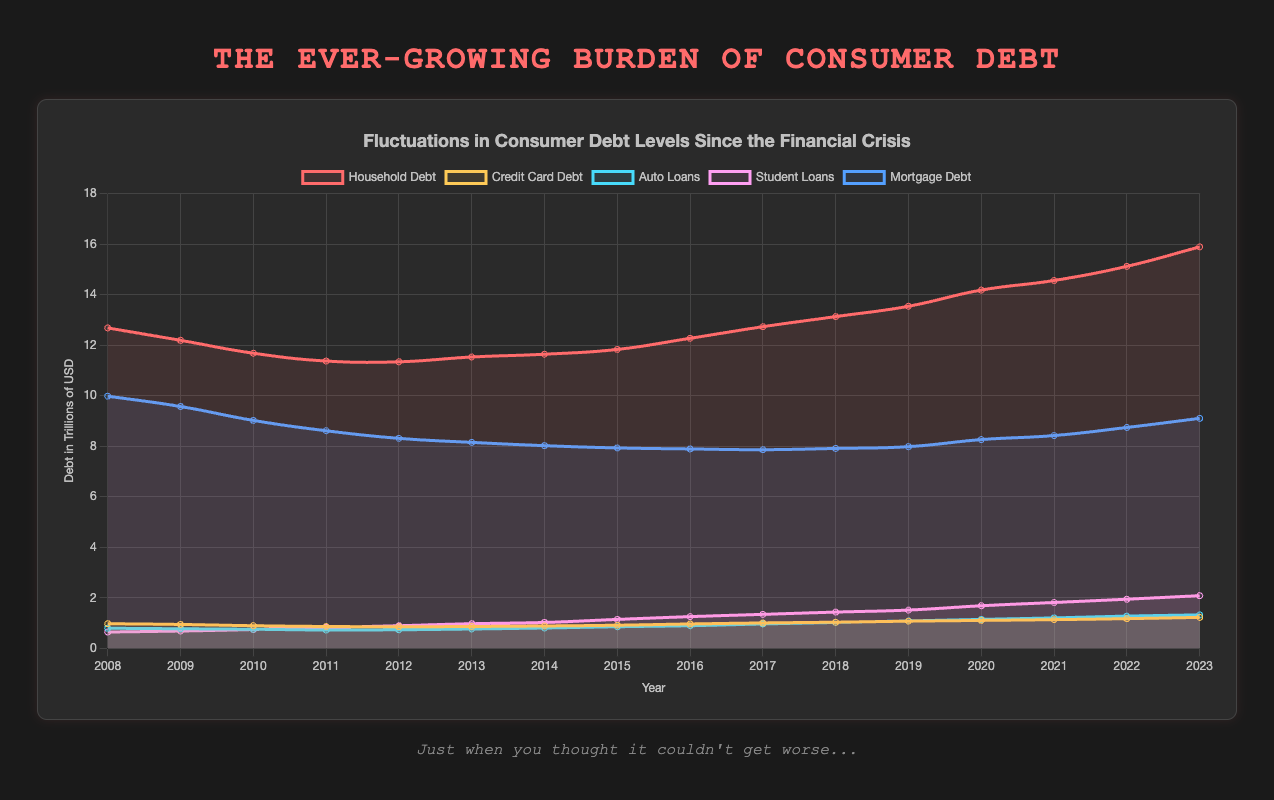Which type of debt has seen the highest increase from 2008 to 2023? To determine the highest increase, subtract the 2008 debt values from the 2023 values for each debt type. Household Debt: 15.89 - 12.68 = 3.21, Credit Card Debt: 1.22 - 0.97 = 0.25, Auto Loans: 1.32 - 0.79 = 0.53, Student Loans: 2.08 - 0.64 = 1.44, Mortgage Debt: 9.1 - 9.98 = -0.88. Student Loans have the highest increase of 1.44 trillion USD.
Answer: Student Loans Which debt category shows the most consistent upward trend across the years? To answer, observe the slopes of the lines representing each debt category. Student Loans demonstrate the most consistent upward trend as it continuously increases from 2008 to 2023 without any decline.
Answer: Student Loans In which year did Household Debt surpass the 13 trillion USD mark? Check the Household Debt line for the year where the value exceeds 13 trillion USD. The chart shows that in 2018, Household Debt is at 13.13 trillion USD, marking the first year it surpasses 13 trillion.
Answer: 2018 By how much did mortgage debt decrease from 2008 to its lowest point? Identify the highest point (2008, 9.98 trillion USD) and the lowest point (2014, 8.02 trillion USD). Calculate the decrease as 9.98 - 8.02 = 1.96 trillion USD.
Answer: 1.96 trillion USD Which debt type had the smallest average annual increase? Calculate the total increase for each debt type from 2008 to 2023 and divide by 15 years to find the average annual increase. Mortgage Debt: (-0.88)/15 ≈ -0.059, Household Debt: 3.21/15 ≈ 0.214, Credit Card Debt: 0.25/15 ≈ 0.017, Auto Loans: 0.53/15 ≈ 0.035, Student Loans: 1.44/15 ≈ 0.096. Credit Card Debt has the smallest average annual increase.
Answer: Credit Card Debt What is the total debt for all categories in 2023? Sum the 2023 debt values for each category: 15.89 (Household) + 1.22 (Credit Card) + 1.32 (Auto Loans) + 2.08 (Student Loans) + 9.1 (Mortgage) = 29.61 trillion USD.
Answer: 29.61 trillion USD Compare the mortgage debt in 2008 and in 2023. Which year had higher mortgage debt and by how much? Compare values from 2008 (9.98 trillion USD) and 2023 (9.1 trillion USD). 2008 had higher mortgage debt. The difference is 9.98 - 9.1 = 0.88 trillion USD.
Answer: 2008 by 0.88 trillion USD Which year had the lowest credit card debt and what was its value? Examine the Credit Card Debt line for the lowest point. In 2012, Credit Card Debt is at its lowest with 0.85 trillion USD.
Answer: 2012, 0.85 trillion USD What is the rate of increase in student loans from 2018 to 2023? Calculate the difference in student loans from 2018 (1.43 trillion USD) to 2023 (2.08 trillion USD). The increase is 2.08 - 1.43 = 0.65 trillion USD over 5 years. The annual rate is 0.65/5 = 0.13 trillion USD/year.
Answer: 0.13 trillion USD/year 